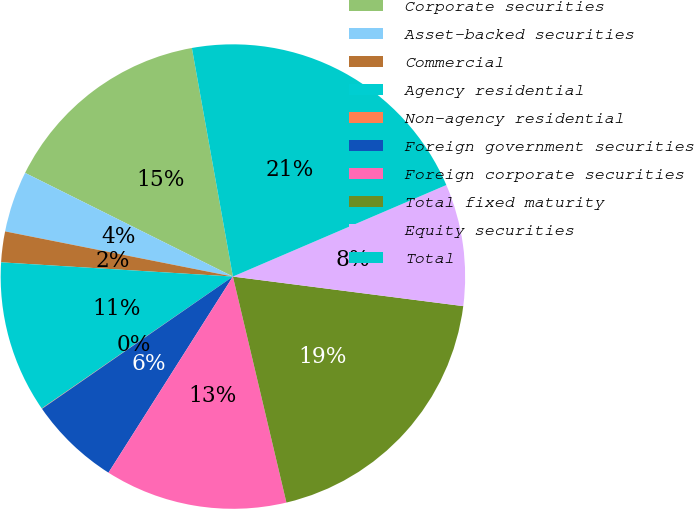Convert chart to OTSL. <chart><loc_0><loc_0><loc_500><loc_500><pie_chart><fcel>Corporate securities<fcel>Asset-backed securities<fcel>Commercial<fcel>Agency residential<fcel>Non-agency residential<fcel>Foreign government securities<fcel>Foreign corporate securities<fcel>Total fixed maturity<fcel>Equity securities<fcel>Total<nl><fcel>14.81%<fcel>4.25%<fcel>2.14%<fcel>10.59%<fcel>0.03%<fcel>6.36%<fcel>12.7%<fcel>19.27%<fcel>8.48%<fcel>21.38%<nl></chart> 